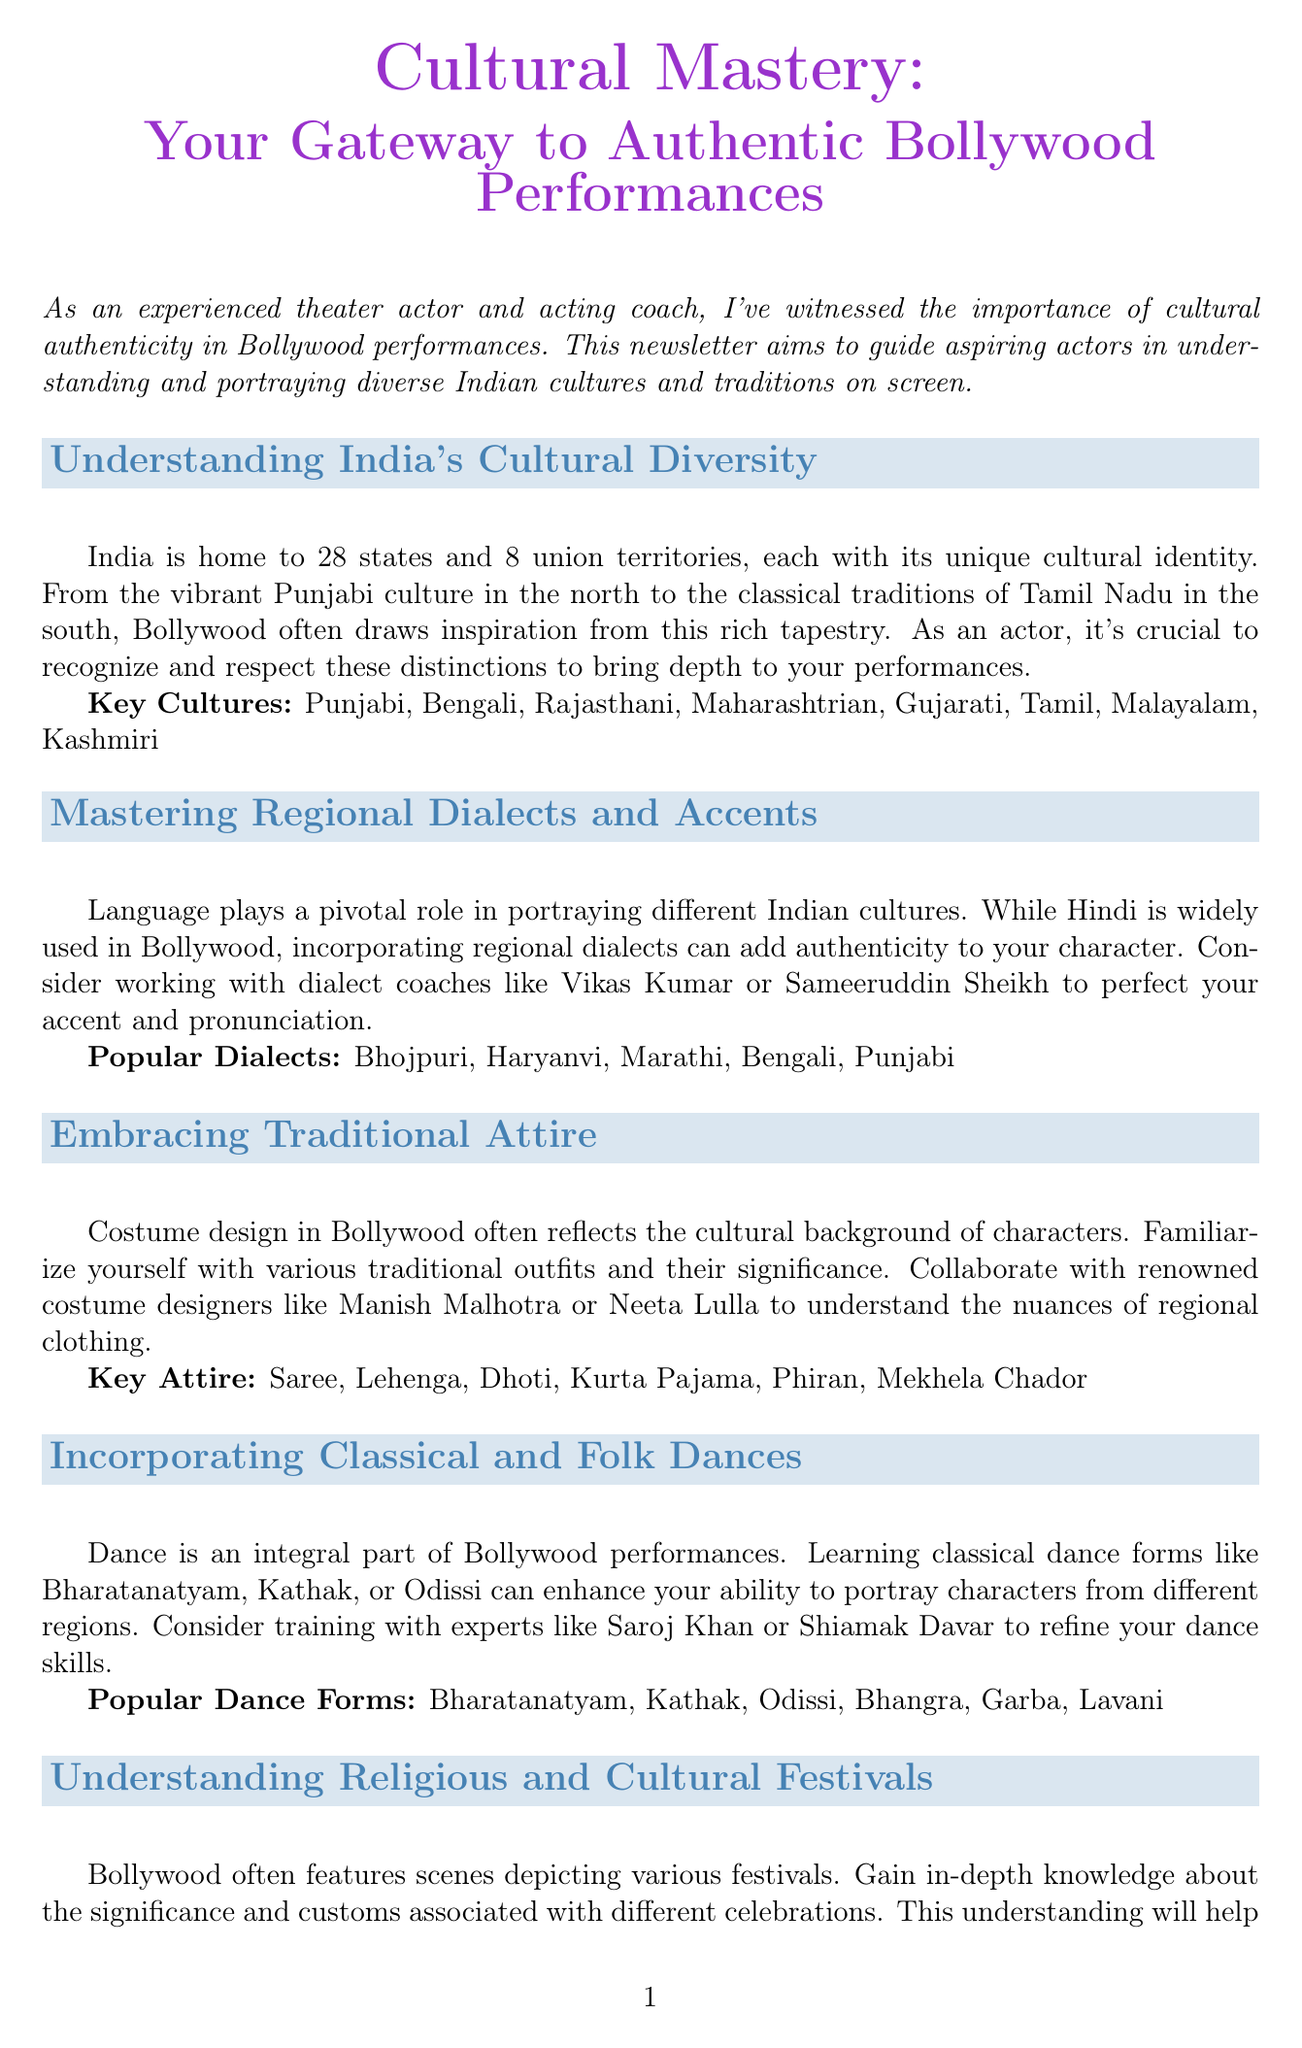What is the title of the newsletter? The title of the newsletter, as stated at the beginning, is highlighted in a larger font and is the main focus of the document.
Answer: Cultural Mastery: Your Gateway to Authentic Bollywood Performances How many states and union territories are mentioned? The document mentions the number of states and union territories in India, which is crucial to understanding cultural diversity.
Answer: 28 states and 8 union territories Name one key culture from the list provided. The newsletter lists various key cultures, and knowing any one of them demonstrates understanding of India's diversity.
Answer: Punjabi Who is suggested for dialect coaching? The document provides names of coaches who specialize in dialect coaching, which is essential for mastering regional accents.
Answer: Vikas Kumar What is one popular dance form mentioned? The newsletter highlights various dance forms; selecting one shows knowledge of the cultural elements in Bollywood performances.
Answer: Bharatanatyam What is the significance of food in the document? The newsletter discusses how food is integral to Indian culture and Bollywood films, indicating why familiarity with it is important.
Answer: Authenticity What gesture is referred to as a key aspect of non-verbal communication? Understanding gestures is vital for actors; the document lists specific ones, highlighting their importance in performances.
Answer: Namaste gesture Which costume designer is mentioned in the newsletter? The document references renowned costume designers, providing insight into where actors can learn about traditional attire.
Answer: Manish Malhotra 